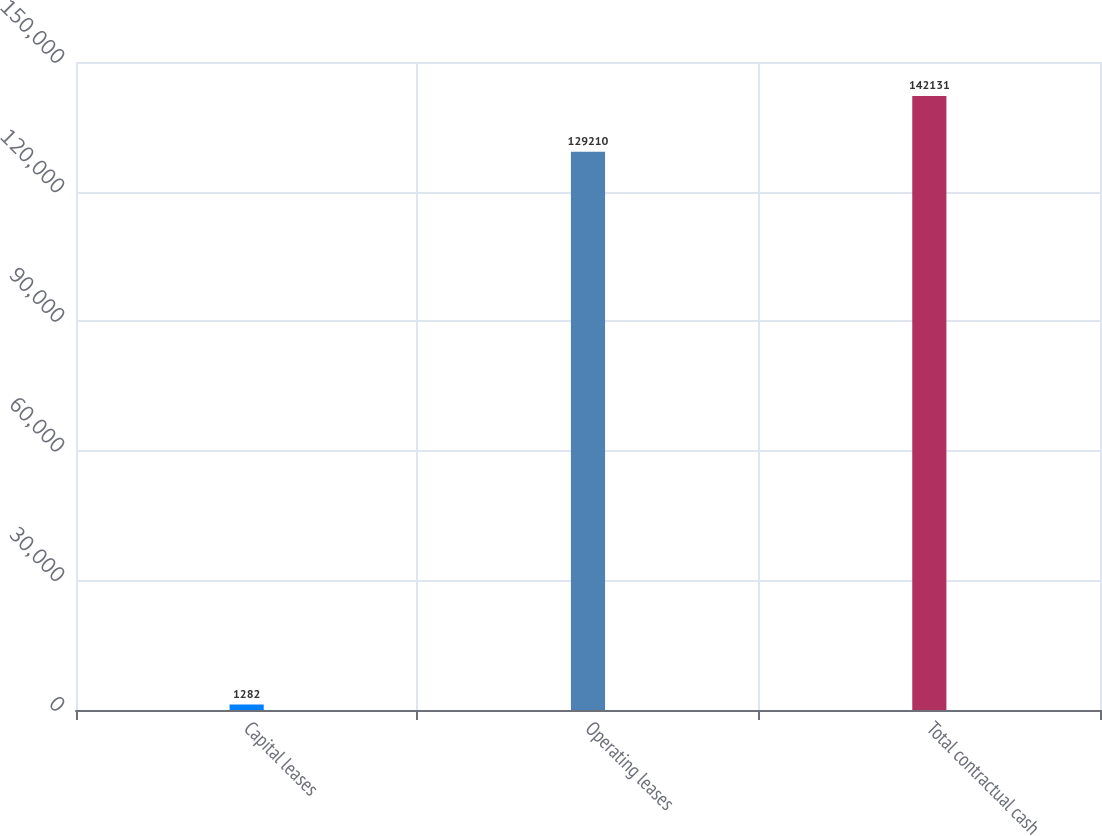Convert chart to OTSL. <chart><loc_0><loc_0><loc_500><loc_500><bar_chart><fcel>Capital leases<fcel>Operating leases<fcel>Total contractual cash<nl><fcel>1282<fcel>129210<fcel>142131<nl></chart> 